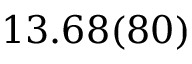Convert formula to latex. <formula><loc_0><loc_0><loc_500><loc_500>1 3 . 6 8 ( 8 0 )</formula> 